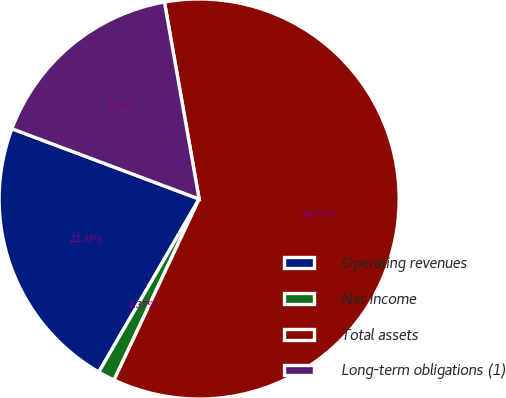Convert chart. <chart><loc_0><loc_0><loc_500><loc_500><pie_chart><fcel>Operating revenues<fcel>Net Income<fcel>Total assets<fcel>Long-term obligations (1)<nl><fcel>22.35%<fcel>1.37%<fcel>59.77%<fcel>16.51%<nl></chart> 